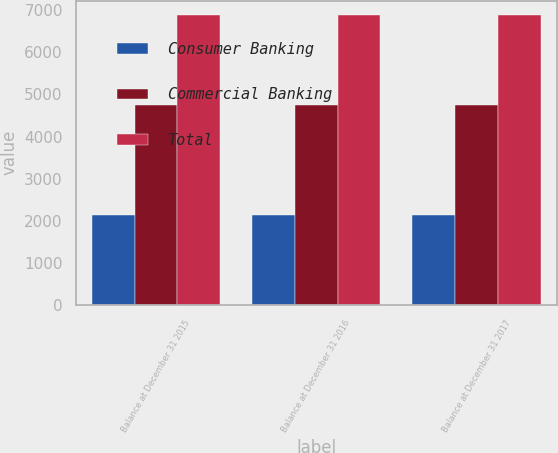Convert chart to OTSL. <chart><loc_0><loc_0><loc_500><loc_500><stacked_bar_chart><ecel><fcel>Balance at December 31 2015<fcel>Balance at December 31 2016<fcel>Balance at December 31 2017<nl><fcel>Consumer Banking<fcel>2136<fcel>2136<fcel>2136<nl><fcel>Commercial Banking<fcel>4740<fcel>4740<fcel>4751<nl><fcel>Total<fcel>6876<fcel>6876<fcel>6887<nl></chart> 